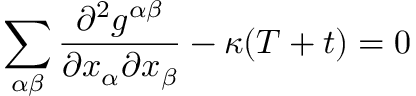<formula> <loc_0><loc_0><loc_500><loc_500>\sum _ { \alpha \beta } \frac { \partial ^ { 2 } g ^ { \alpha \beta } } { \partial x _ { \alpha } \partial x _ { \beta } } - \kappa ( T + t ) = 0</formula> 